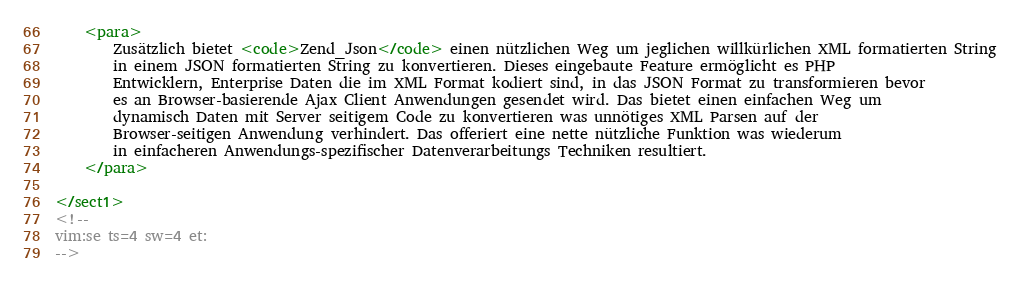<code> <loc_0><loc_0><loc_500><loc_500><_XML_>
    <para>
        Zusätzlich bietet <code>Zend_Json</code> einen nützlichen Weg um jeglichen willkürlichen XML formatierten String
        in einem JSON formatierten String zu konvertieren. Dieses eingebaute Feature ermöglicht es PHP
        Entwicklern, Enterprise Daten die im XML Format kodiert sind, in das JSON Format zu transformieren bevor
        es an Browser-basierende Ajax Client Anwendungen gesendet wird. Das bietet einen einfachen Weg um
        dynamisch Daten mit Server seitigem Code zu konvertieren was unnötiges XML Parsen auf der
        Browser-seitigen Anwendung verhindert. Das offeriert eine nette nützliche Funktion was wiederum
        in einfacheren Anwendungs-spezifischer Datenverarbeitungs Techniken resultiert.
    </para>

</sect1>
<!--
vim:se ts=4 sw=4 et:
--></code> 